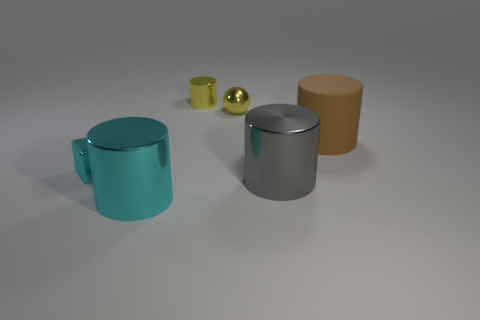How many tiny cyan shiny things are there?
Provide a short and direct response. 1. There is a large cylinder that is behind the cyan thing behind the big cyan cylinder; what is its material?
Provide a succinct answer. Rubber. There is a big thing that is the same material as the big gray cylinder; what is its color?
Offer a very short reply. Cyan. What is the shape of the thing that is the same color as the tiny metallic cylinder?
Provide a short and direct response. Sphere. Does the cyan object on the right side of the metallic cube have the same size as the cylinder that is right of the gray cylinder?
Make the answer very short. Yes. How many blocks are big red metal things or yellow shiny things?
Provide a short and direct response. 0. Is the tiny object that is in front of the matte thing made of the same material as the large brown cylinder?
Ensure brevity in your answer.  No. What number of other objects are the same size as the block?
Your answer should be compact. 2. How many big objects are metallic cylinders or brown rubber things?
Your answer should be very brief. 3. Is the tiny ball the same color as the tiny metal cylinder?
Ensure brevity in your answer.  Yes. 